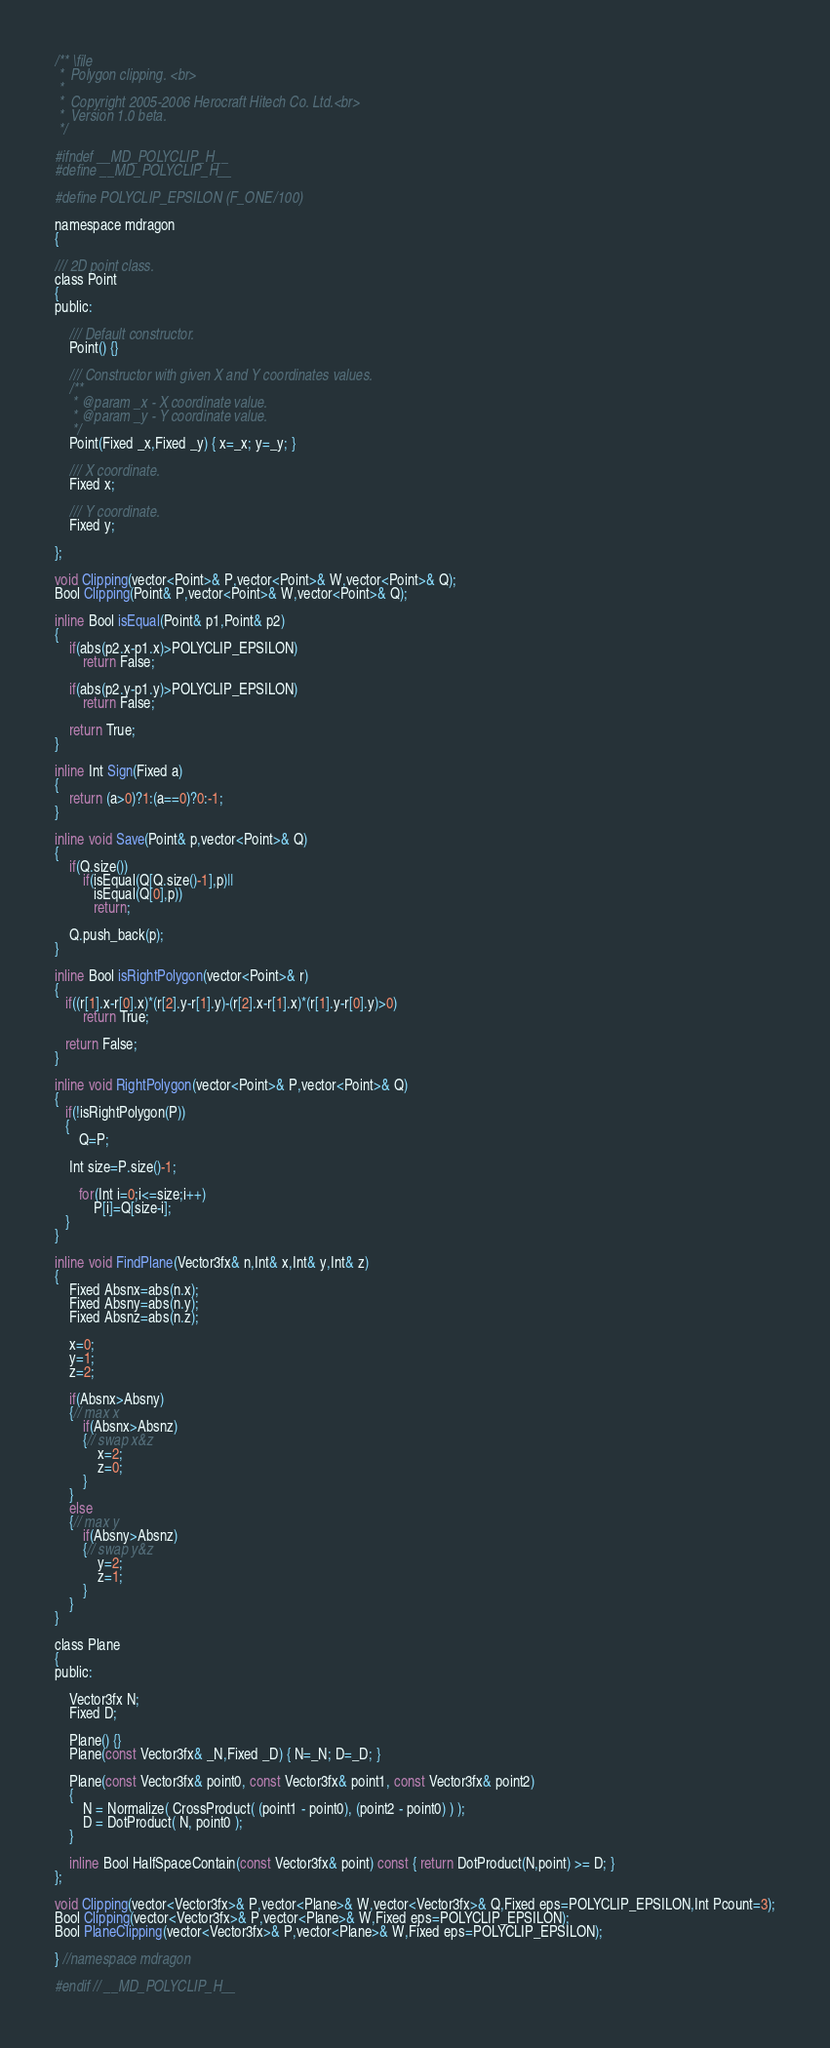<code> <loc_0><loc_0><loc_500><loc_500><_C_>/** \file
 *	Polygon clipping. <br>
 *
 *	Copyright 2005-2006 Herocraft Hitech Co. Ltd.<br>
 *	Version 1.0 beta.
 */

#ifndef __MD_POLYCLIP_H__
#define __MD_POLYCLIP_H__

#define POLYCLIP_EPSILON (F_ONE/100)

namespace mdragon
{

/// 2D point class.
class Point
{
public:

	/// Default constructor.
	Point() {}

	/// Constructor with given X and Y coordinates values.
	/**
	 * @param _x - X coordinate value.
	 * @param _y - Y coordinate value.
	 */
	Point(Fixed _x,Fixed _y) { x=_x; y=_y; }
	
	/// X coordinate.
	Fixed x;

	/// Y coordinate.
	Fixed y;

};

void Clipping(vector<Point>& P,vector<Point>& W,vector<Point>& Q);
Bool Clipping(Point& P,vector<Point>& W,vector<Point>& Q);

inline Bool isEqual(Point& p1,Point& p2)
{
	if(abs(p2.x-p1.x)>POLYCLIP_EPSILON)
		return False;

	if(abs(p2.y-p1.y)>POLYCLIP_EPSILON)
		return False;

	return True;
}

inline Int Sign(Fixed a)
{
	return (a>0)?1:(a==0)?0:-1;
}

inline void Save(Point& p,vector<Point>& Q)
{
	if(Q.size())
		if(isEqual(Q[Q.size()-1],p)||
		   isEqual(Q[0],p))
		   return;

	Q.push_back(p);
}

inline Bool isRightPolygon(vector<Point>& r)
{
   if((r[1].x-r[0].x)*(r[2].y-r[1].y)-(r[2].x-r[1].x)*(r[1].y-r[0].y)>0)
		return True;

   return False;
}

inline void RightPolygon(vector<Point>& P,vector<Point>& Q)
{
   if(!isRightPolygon(P))
   {
	   Q=P;

	Int size=P.size()-1;

	   for(Int i=0;i<=size;i++)
		   P[i]=Q[size-i];
   }
}

inline void FindPlane(Vector3fx& n,Int& x,Int& y,Int& z)
{
	Fixed Absnx=abs(n.x);
	Fixed Absny=abs(n.y);
	Fixed Absnz=abs(n.z);

	x=0;
	y=1;
	z=2;

	if(Absnx>Absny)
	{// max x
		if(Absnx>Absnz)
		{// swap x&z
			x=2;
			z=0;
		}
	}
	else
	{// max y
		if(Absny>Absnz)
		{// swap y&z
			y=2;
			z=1;
		}
	}
}

class Plane
{
public:

	Vector3fx N;
	Fixed D;

	Plane() {}
	Plane(const Vector3fx& _N,Fixed _D) { N=_N; D=_D; }

	Plane(const Vector3fx& point0, const Vector3fx& point1, const Vector3fx& point2)
	{
		N = Normalize( CrossProduct( (point1 - point0), (point2 - point0) ) );
		D = DotProduct( N, point0 );
	}

    inline Bool HalfSpaceContain(const Vector3fx& point) const { return DotProduct(N,point) >= D; }
};

void Clipping(vector<Vector3fx>& P,vector<Plane>& W,vector<Vector3fx>& Q,Fixed eps=POLYCLIP_EPSILON,Int Pcount=3);
Bool Clipping(vector<Vector3fx>& P,vector<Plane>& W,Fixed eps=POLYCLIP_EPSILON);
Bool PlaneClipping(vector<Vector3fx>& P,vector<Plane>& W,Fixed eps=POLYCLIP_EPSILON);

} //namespace mdragon

#endif // __MD_POLYCLIP_H__
</code> 